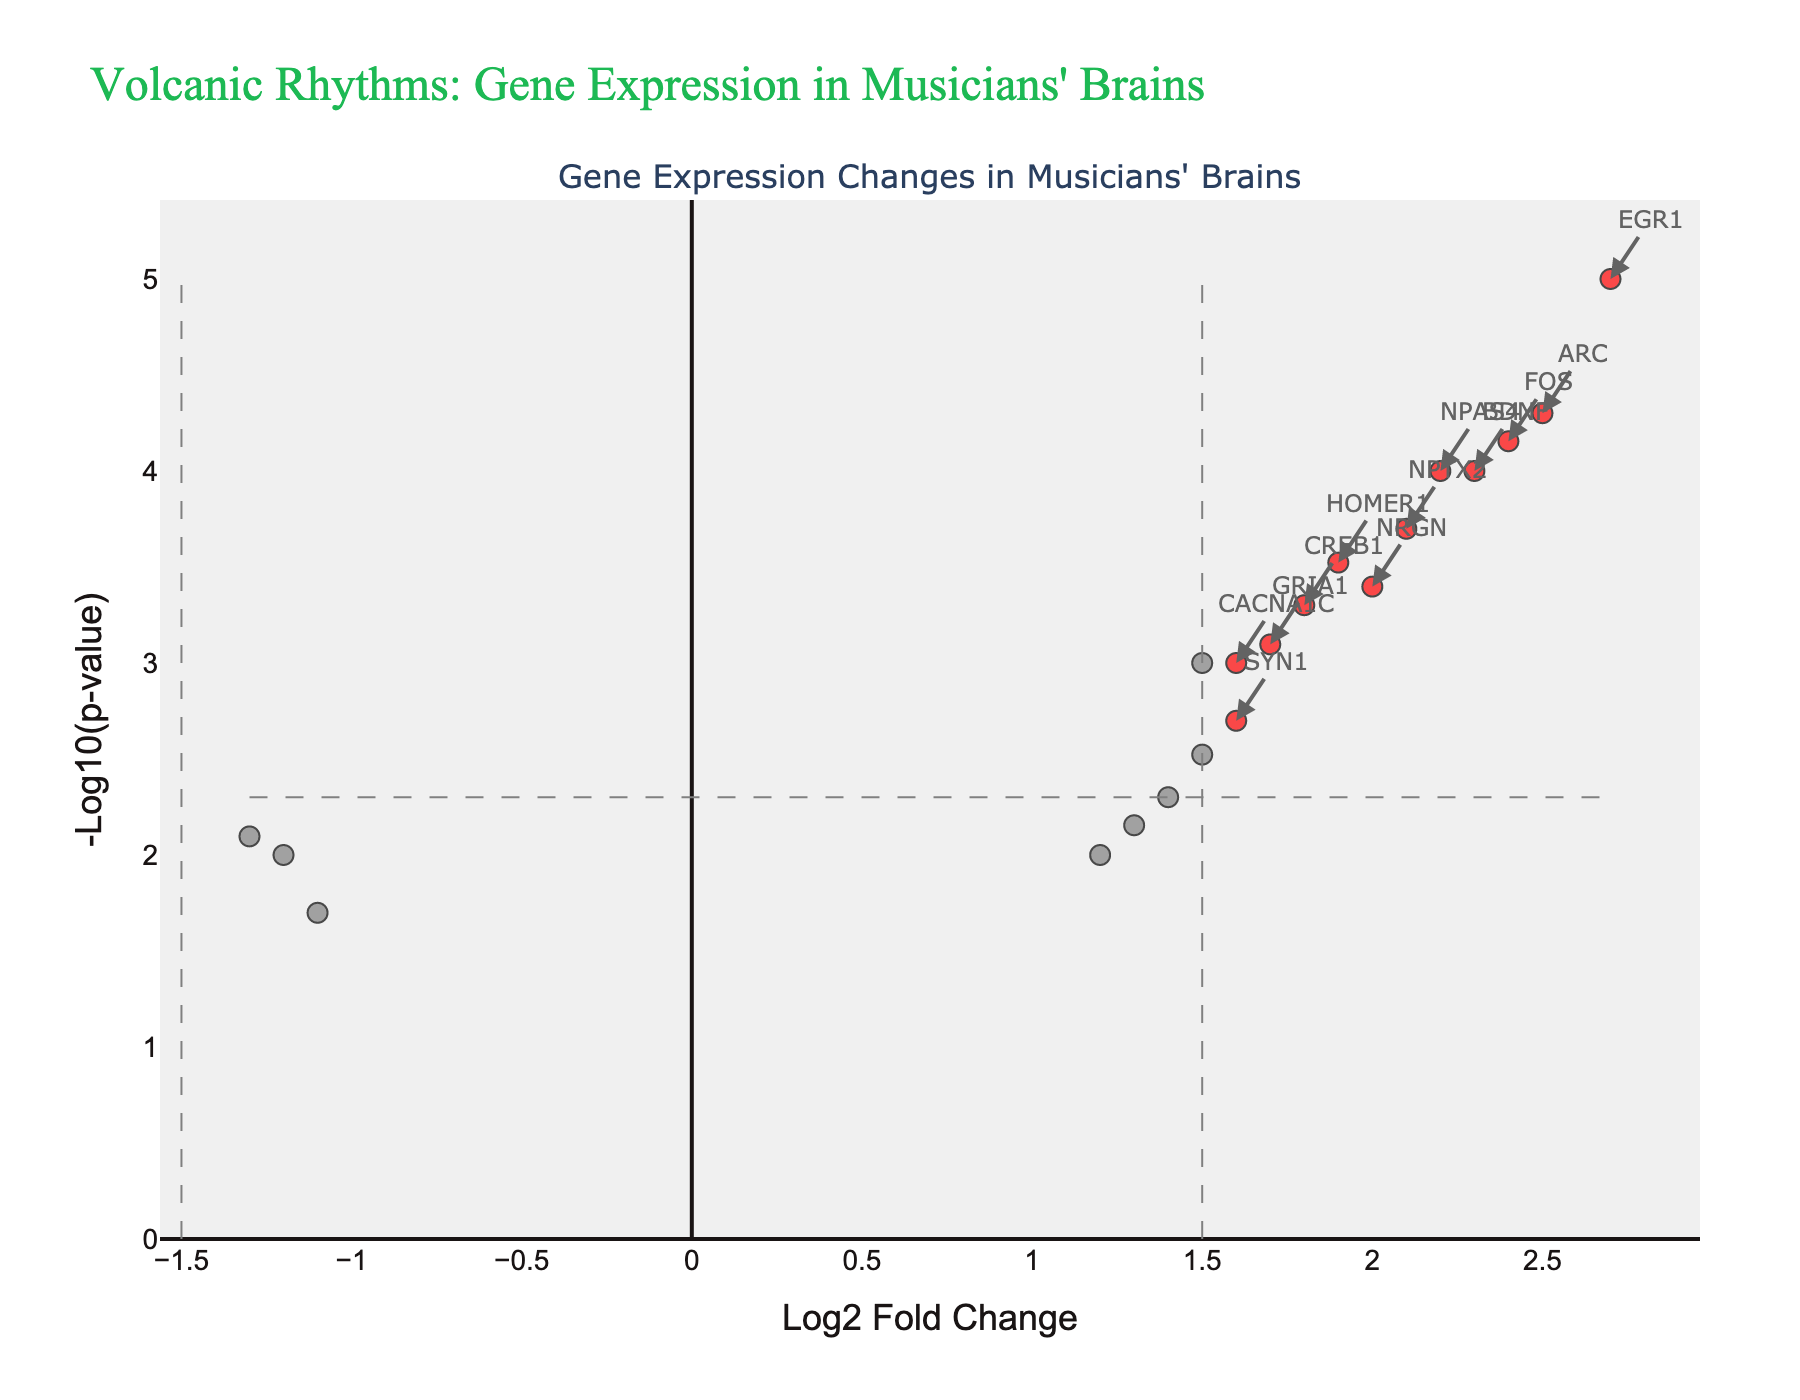How many genes are highlighted in red? To find the number of genes highlighted in red, count the data points represented by red dots in the figure. These red dots correspond to genes with a log2 fold change greater than 1.5 or less than -1.5 and with a p-value less than 0.005.
Answer: 12 Which gene shows the most significant upregulation? The most significant upregulated gene will be the one with the highest -log10(p-value) and a positive log2 fold change. In the plot, this gene will be among the highest red dots in the positive x-axis direction.
Answer: EGR1 Which axis measures the change in gene expression? Examine the axis titles to determine which axis measures the change in gene expression. The x-axis represents "Log2 Fold Change," which measures the change in gene expression.
Answer: x-axis What is the threshold value for -log10(p-value) used to determine significance? Identify the horizontal threshold line and note the corresponding y-axis value, which represents the -log10(p-value) threshold. From the figure, the threshold value on the y-axis is -log10(0.005).
Answer: 2.301 Which gene has the lowest p-value among the downregulated genes? To find the downregulated gene with the lowest p-value, look for the blue dot with the highest -log10(p-value) on the left side of the figure (negative log2 fold change).
Answer: GRIN2B How many genes are significantly downregulated? Count the number of blue dots, which represent the significantly downregulated genes with a log2 fold change less than -1.5 and a p-value less than 0.005.
Answer: 3 What is the log2 fold change value of the gene BDNF? Locate the label for the gene BDNF in the figure and find its corresponding position on the x-axis to determine the log2 fold change value.
Answer: 2.3 Is SYN1 significantly upregulated? Locate the data point for SYN1 and determine if it falls into the red region, which means it should have a log2 fold change greater than 1.5 and a p-value less than 0.005.
Answer: No Which gene appears second in terms of significance in upregulation? Identify the second-highest red dot on the y-axis (after EGR1). This corresponds to the second most significant upregulated gene.
Answer: ARC What is the range of log2 fold change values? Look at the x-axis to determine the minimum and maximum log2 fold change values shown in the figure. The range is the difference between these two values.
Answer: -1.3 to 2.7 